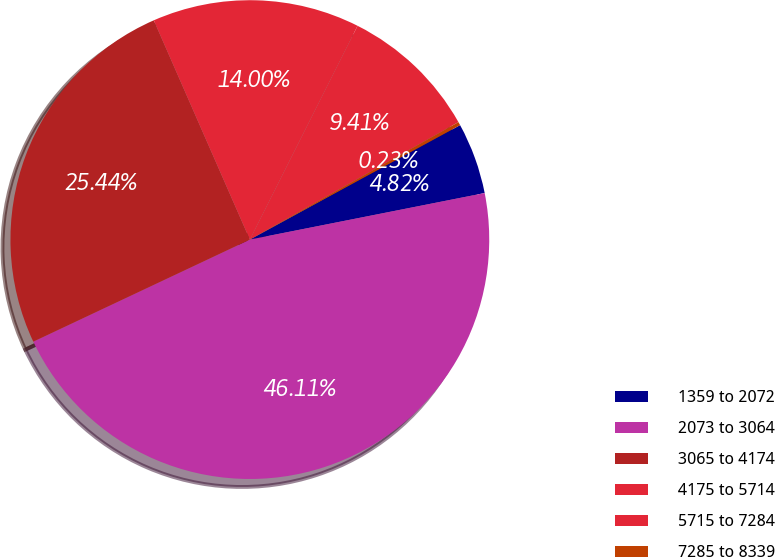<chart> <loc_0><loc_0><loc_500><loc_500><pie_chart><fcel>1359 to 2072<fcel>2073 to 3064<fcel>3065 to 4174<fcel>4175 to 5714<fcel>5715 to 7284<fcel>7285 to 8339<nl><fcel>4.82%<fcel>46.11%<fcel>25.44%<fcel>14.0%<fcel>9.41%<fcel>0.23%<nl></chart> 